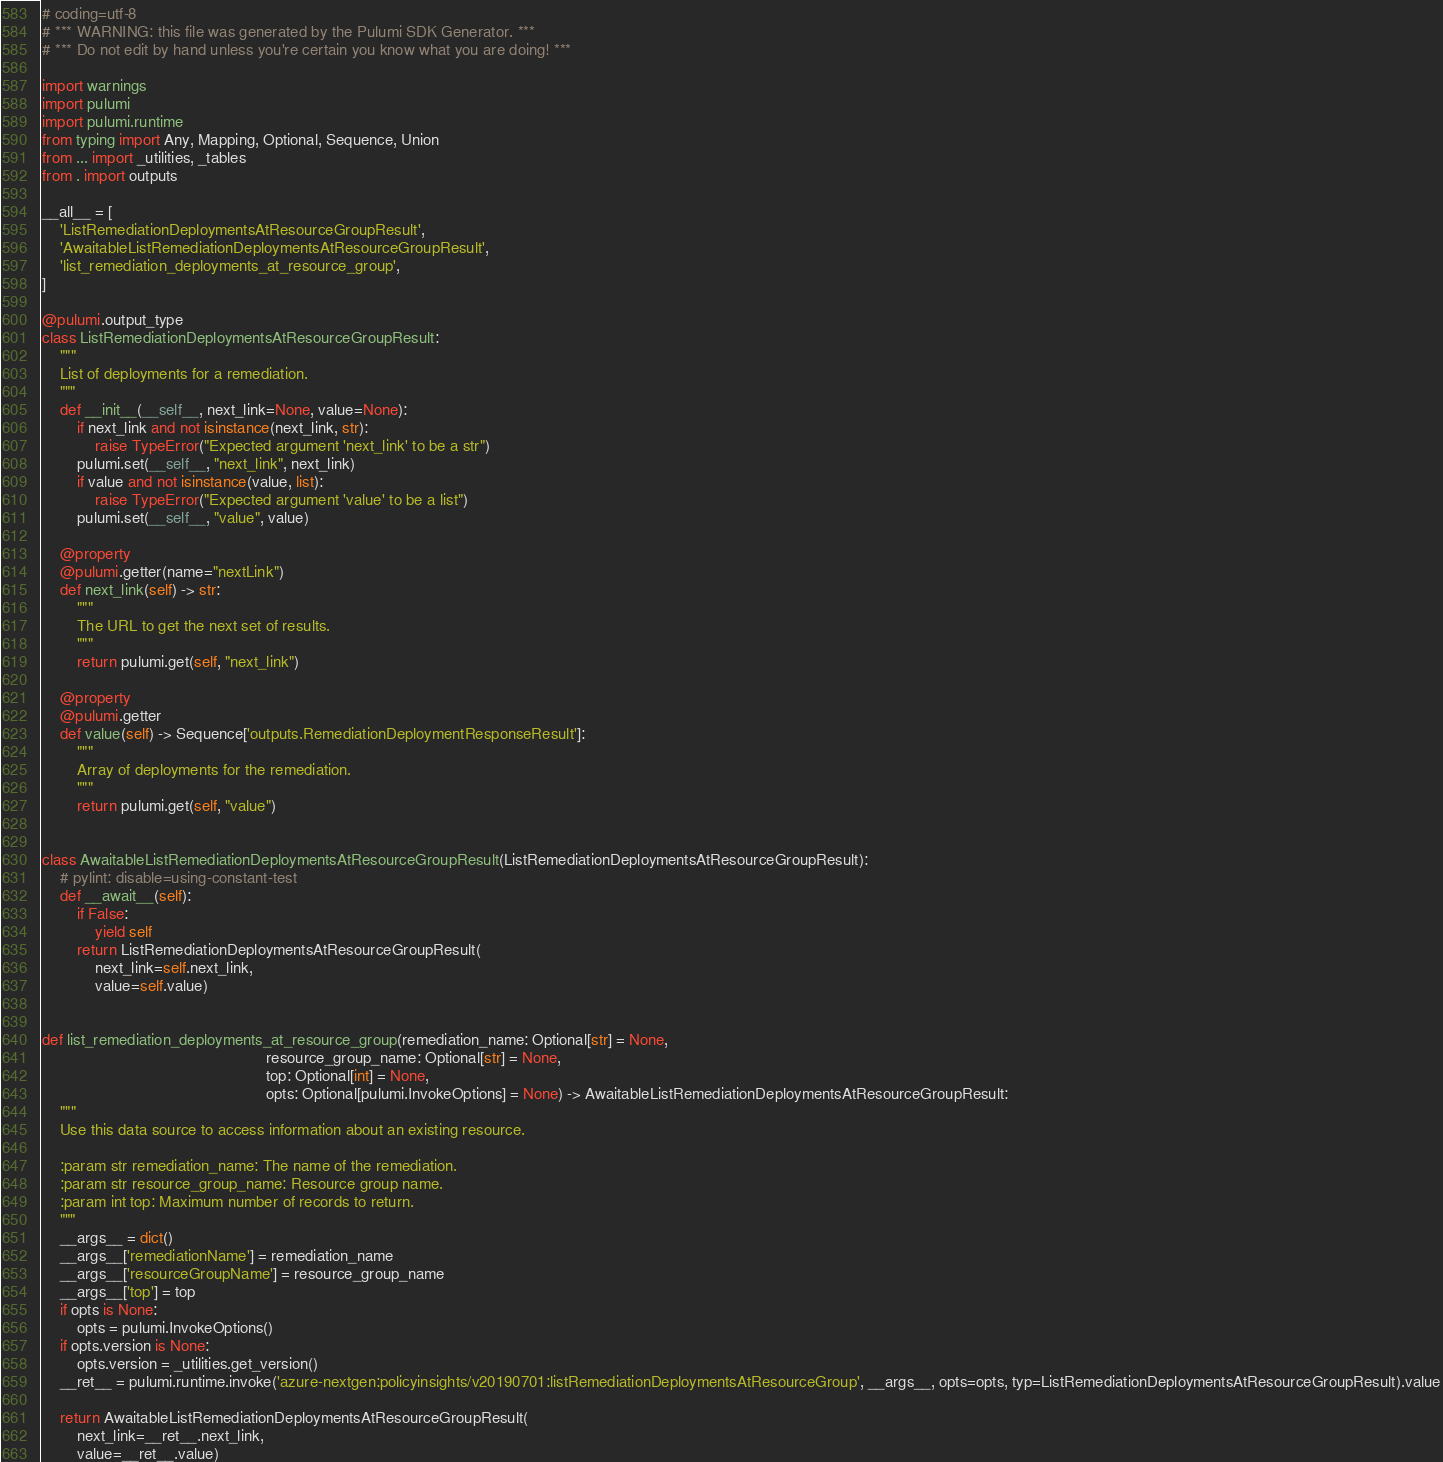<code> <loc_0><loc_0><loc_500><loc_500><_Python_># coding=utf-8
# *** WARNING: this file was generated by the Pulumi SDK Generator. ***
# *** Do not edit by hand unless you're certain you know what you are doing! ***

import warnings
import pulumi
import pulumi.runtime
from typing import Any, Mapping, Optional, Sequence, Union
from ... import _utilities, _tables
from . import outputs

__all__ = [
    'ListRemediationDeploymentsAtResourceGroupResult',
    'AwaitableListRemediationDeploymentsAtResourceGroupResult',
    'list_remediation_deployments_at_resource_group',
]

@pulumi.output_type
class ListRemediationDeploymentsAtResourceGroupResult:
    """
    List of deployments for a remediation.
    """
    def __init__(__self__, next_link=None, value=None):
        if next_link and not isinstance(next_link, str):
            raise TypeError("Expected argument 'next_link' to be a str")
        pulumi.set(__self__, "next_link", next_link)
        if value and not isinstance(value, list):
            raise TypeError("Expected argument 'value' to be a list")
        pulumi.set(__self__, "value", value)

    @property
    @pulumi.getter(name="nextLink")
    def next_link(self) -> str:
        """
        The URL to get the next set of results.
        """
        return pulumi.get(self, "next_link")

    @property
    @pulumi.getter
    def value(self) -> Sequence['outputs.RemediationDeploymentResponseResult']:
        """
        Array of deployments for the remediation.
        """
        return pulumi.get(self, "value")


class AwaitableListRemediationDeploymentsAtResourceGroupResult(ListRemediationDeploymentsAtResourceGroupResult):
    # pylint: disable=using-constant-test
    def __await__(self):
        if False:
            yield self
        return ListRemediationDeploymentsAtResourceGroupResult(
            next_link=self.next_link,
            value=self.value)


def list_remediation_deployments_at_resource_group(remediation_name: Optional[str] = None,
                                                   resource_group_name: Optional[str] = None,
                                                   top: Optional[int] = None,
                                                   opts: Optional[pulumi.InvokeOptions] = None) -> AwaitableListRemediationDeploymentsAtResourceGroupResult:
    """
    Use this data source to access information about an existing resource.

    :param str remediation_name: The name of the remediation.
    :param str resource_group_name: Resource group name.
    :param int top: Maximum number of records to return.
    """
    __args__ = dict()
    __args__['remediationName'] = remediation_name
    __args__['resourceGroupName'] = resource_group_name
    __args__['top'] = top
    if opts is None:
        opts = pulumi.InvokeOptions()
    if opts.version is None:
        opts.version = _utilities.get_version()
    __ret__ = pulumi.runtime.invoke('azure-nextgen:policyinsights/v20190701:listRemediationDeploymentsAtResourceGroup', __args__, opts=opts, typ=ListRemediationDeploymentsAtResourceGroupResult).value

    return AwaitableListRemediationDeploymentsAtResourceGroupResult(
        next_link=__ret__.next_link,
        value=__ret__.value)
</code> 